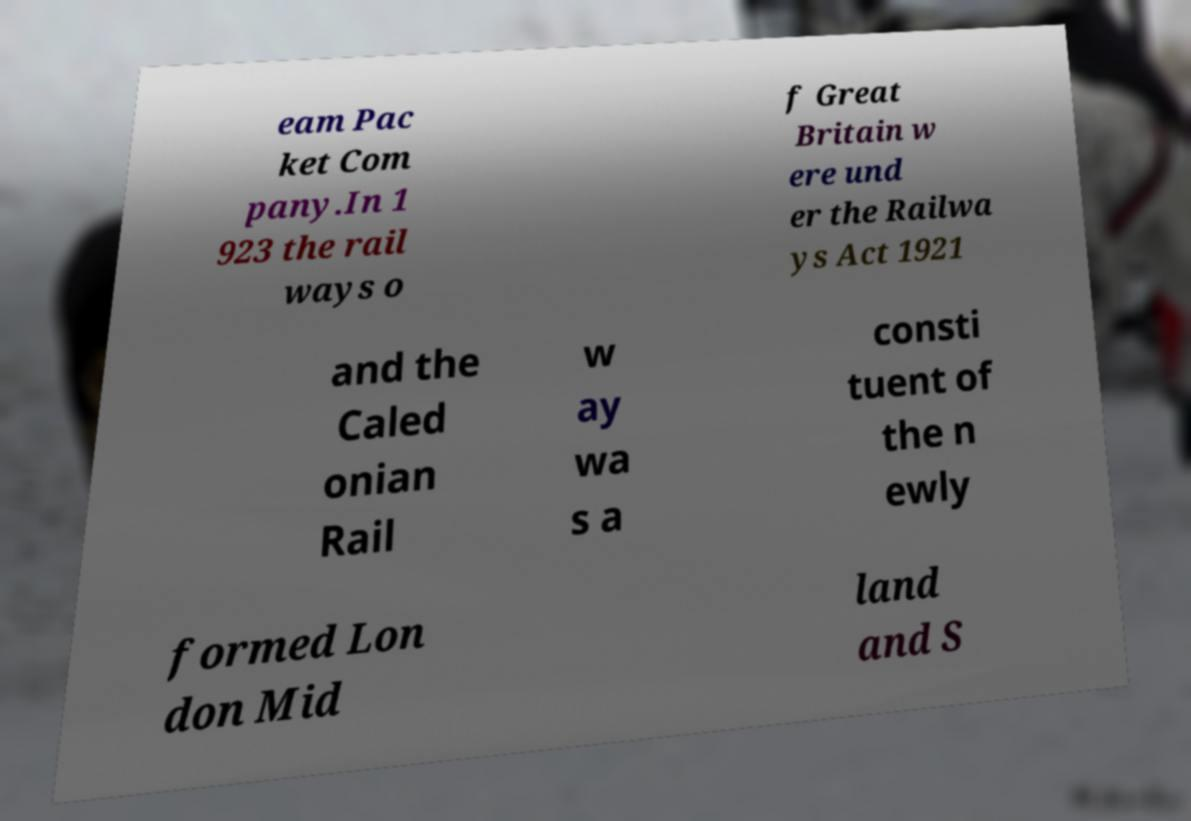Please read and relay the text visible in this image. What does it say? eam Pac ket Com pany.In 1 923 the rail ways o f Great Britain w ere und er the Railwa ys Act 1921 and the Caled onian Rail w ay wa s a consti tuent of the n ewly formed Lon don Mid land and S 